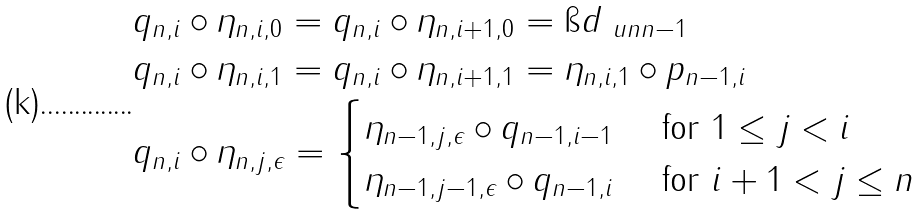Convert formula to latex. <formula><loc_0><loc_0><loc_500><loc_500>& q _ { n , i } \circ \eta _ { n , i , 0 } = q _ { n , i } \circ \eta _ { n , i + 1 , 0 } = \i d _ { \ u n { n - 1 } } \\ & q _ { n , i } \circ \eta _ { n , i , 1 } = q _ { n , i } \circ \eta _ { n , i + 1 , 1 } = \eta _ { n , i , 1 } \circ p _ { n - 1 , i } \\ & q _ { n , i } \circ \eta _ { n , j , \epsilon } = \begin{cases} \eta _ { n - 1 , j , \epsilon } \circ q _ { n - 1 , i - 1 } & \text { for } 1 \leq j < i \\ \eta _ { n - 1 , j - 1 , \epsilon } \circ q _ { n - 1 , i } & \text { for } i + 1 < j \leq n \\ \end{cases}</formula> 